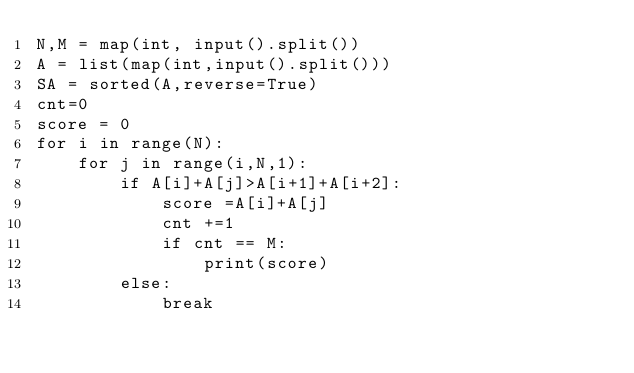Convert code to text. <code><loc_0><loc_0><loc_500><loc_500><_Python_>N,M = map(int, input().split())
A = list(map(int,input().split()))
SA = sorted(A,reverse=True)
cnt=0
score = 0
for i in range(N):
    for j in range(i,N,1):
        if A[i]+A[j]>A[i+1]+A[i+2]:
            score =A[i]+A[j]
            cnt +=1
            if cnt == M:
                print(score)        
        else:
            break</code> 